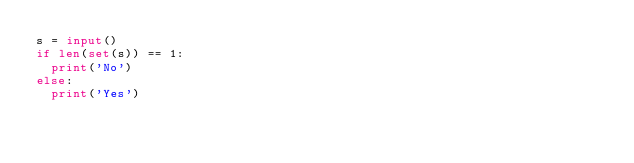<code> <loc_0><loc_0><loc_500><loc_500><_Python_>s = input()
if len(set(s)) == 1:
  print('No')
else:
  print('Yes')</code> 